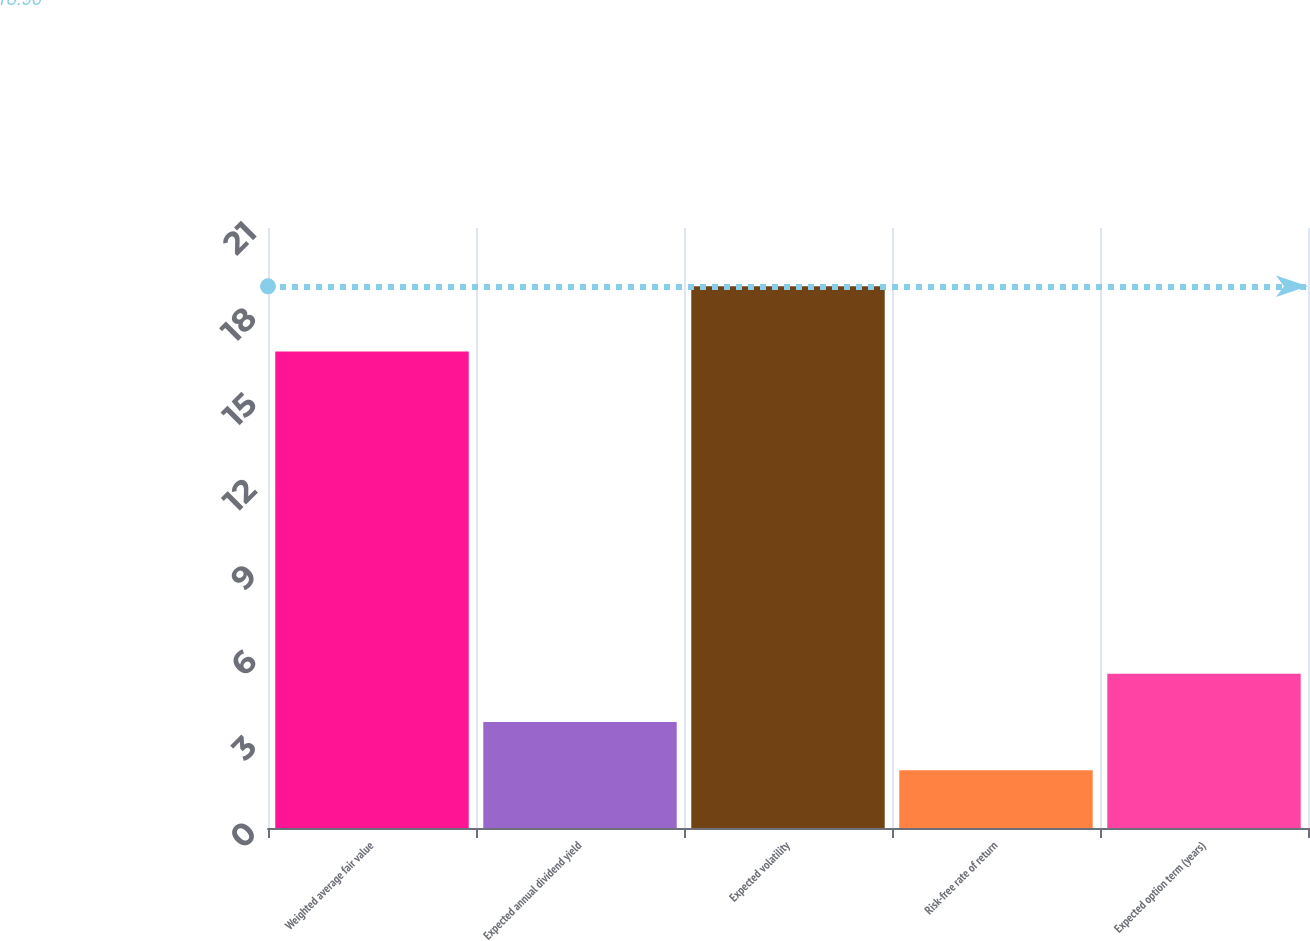<chart> <loc_0><loc_0><loc_500><loc_500><bar_chart><fcel>Weighted average fair value<fcel>Expected annual dividend yield<fcel>Expected volatility<fcel>Risk-free rate of return<fcel>Expected option term (years)<nl><fcel>16.68<fcel>3.71<fcel>18.96<fcel>2.02<fcel>5.4<nl></chart> 